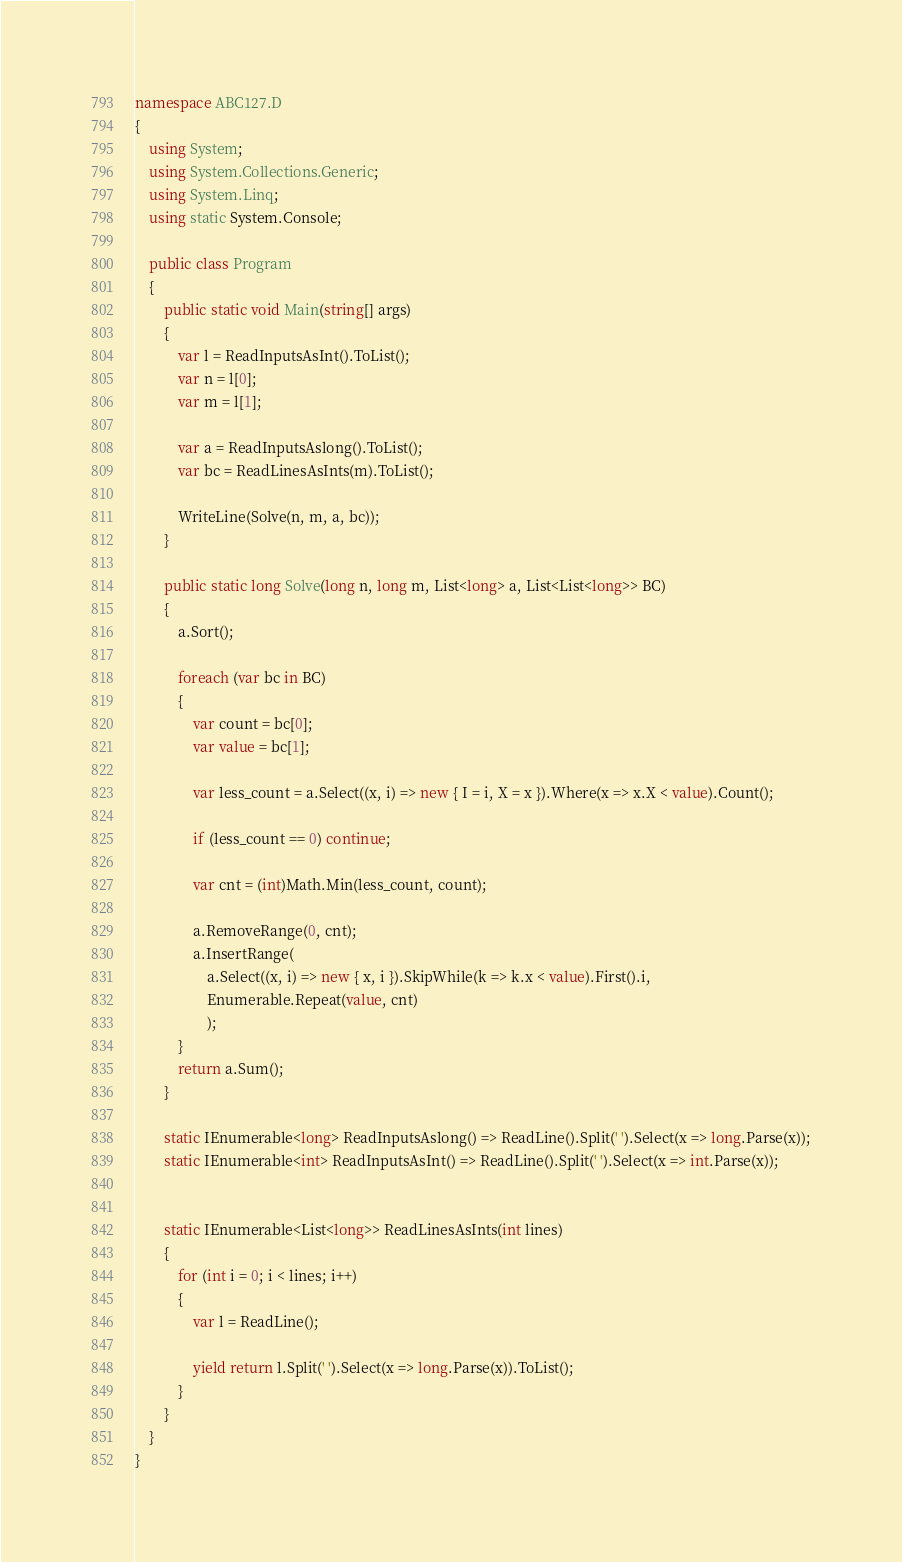Convert code to text. <code><loc_0><loc_0><loc_500><loc_500><_C#_>namespace ABC127.D
{
    using System;
    using System.Collections.Generic;
    using System.Linq;
    using static System.Console;

    public class Program
    {
        public static void Main(string[] args)
        {
            var l = ReadInputsAsInt().ToList();
            var n = l[0];
            var m = l[1];

            var a = ReadInputsAslong().ToList();
            var bc = ReadLinesAsInts(m).ToList();

            WriteLine(Solve(n, m, a, bc));
        }

        public static long Solve(long n, long m, List<long> a, List<List<long>> BC)
        {
            a.Sort();

            foreach (var bc in BC)
            {
                var count = bc[0];
                var value = bc[1];

                var less_count = a.Select((x, i) => new { I = i, X = x }).Where(x => x.X < value).Count();

                if (less_count == 0) continue;

                var cnt = (int)Math.Min(less_count, count);

                a.RemoveRange(0, cnt);
                a.InsertRange(
                    a.Select((x, i) => new { x, i }).SkipWhile(k => k.x < value).First().i,
                    Enumerable.Repeat(value, cnt)
                    );
            }
            return a.Sum();
        }

        static IEnumerable<long> ReadInputsAslong() => ReadLine().Split(' ').Select(x => long.Parse(x));
        static IEnumerable<int> ReadInputsAsInt() => ReadLine().Split(' ').Select(x => int.Parse(x));


        static IEnumerable<List<long>> ReadLinesAsInts(int lines)
        {
            for (int i = 0; i < lines; i++)
            {
                var l = ReadLine();

                yield return l.Split(' ').Select(x => long.Parse(x)).ToList();
            }
        }
    }
}</code> 